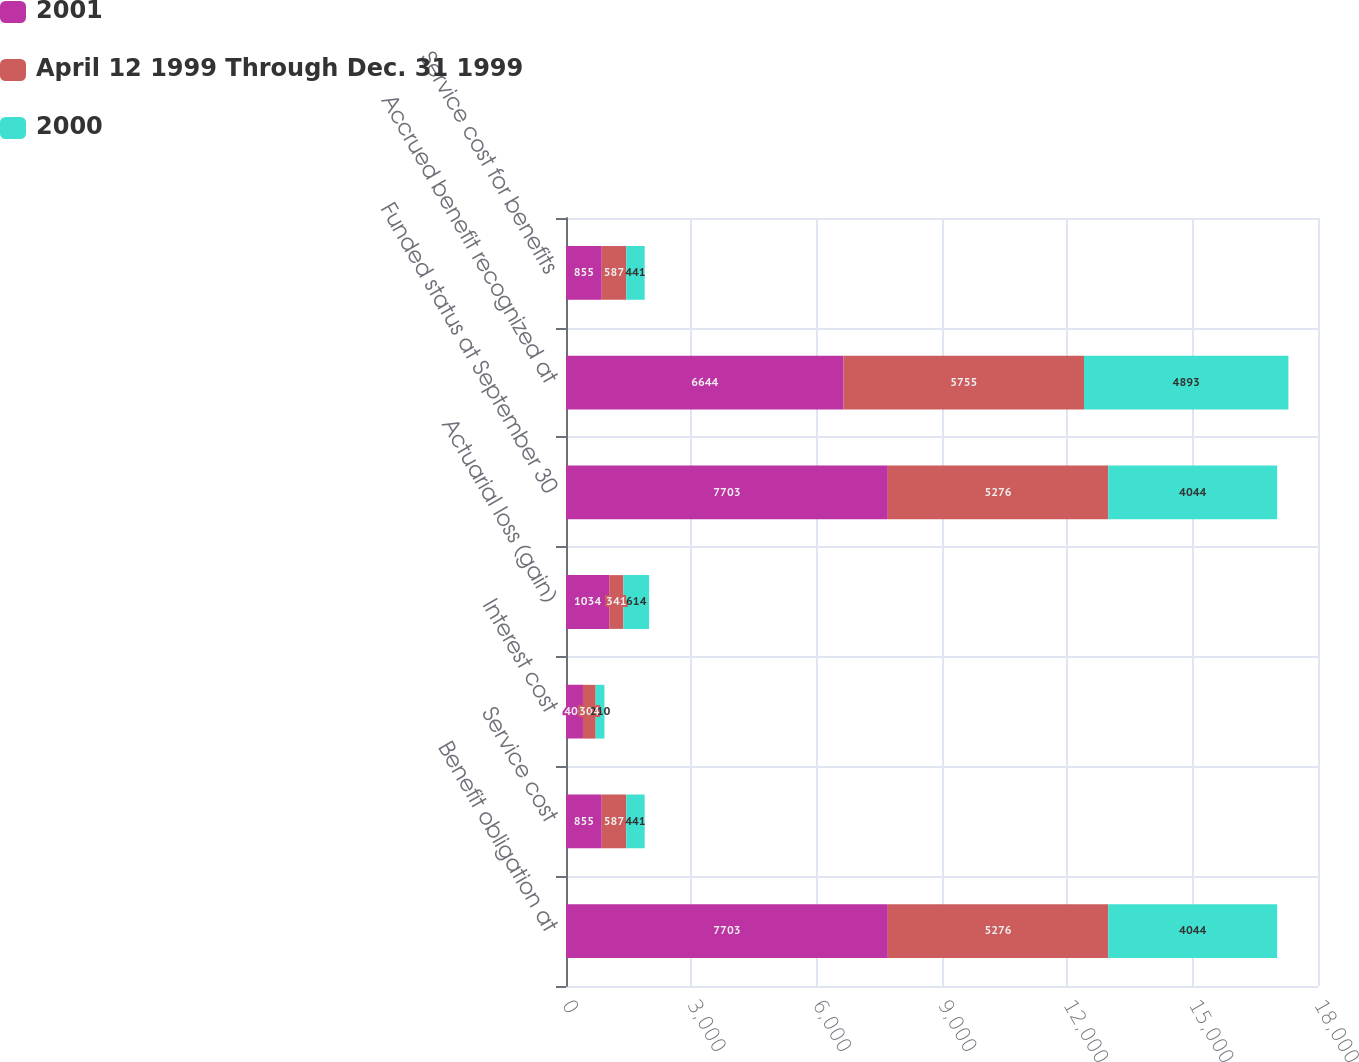Convert chart to OTSL. <chart><loc_0><loc_0><loc_500><loc_500><stacked_bar_chart><ecel><fcel>Benefit obligation at<fcel>Service cost<fcel>Interest cost<fcel>Actuarial loss (gain)<fcel>Funded status at September 30<fcel>Accrued benefit recognized at<fcel>Service cost for benefits<nl><fcel>2001<fcel>7703<fcel>855<fcel>406<fcel>1034<fcel>7703<fcel>6644<fcel>855<nl><fcel>April 12 1999 Through Dec. 31 1999<fcel>5276<fcel>587<fcel>304<fcel>341<fcel>5276<fcel>5755<fcel>587<nl><fcel>2000<fcel>4044<fcel>441<fcel>210<fcel>614<fcel>4044<fcel>4893<fcel>441<nl></chart> 